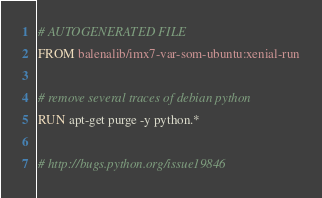<code> <loc_0><loc_0><loc_500><loc_500><_Dockerfile_># AUTOGENERATED FILE
FROM balenalib/imx7-var-som-ubuntu:xenial-run

# remove several traces of debian python
RUN apt-get purge -y python.*

# http://bugs.python.org/issue19846</code> 